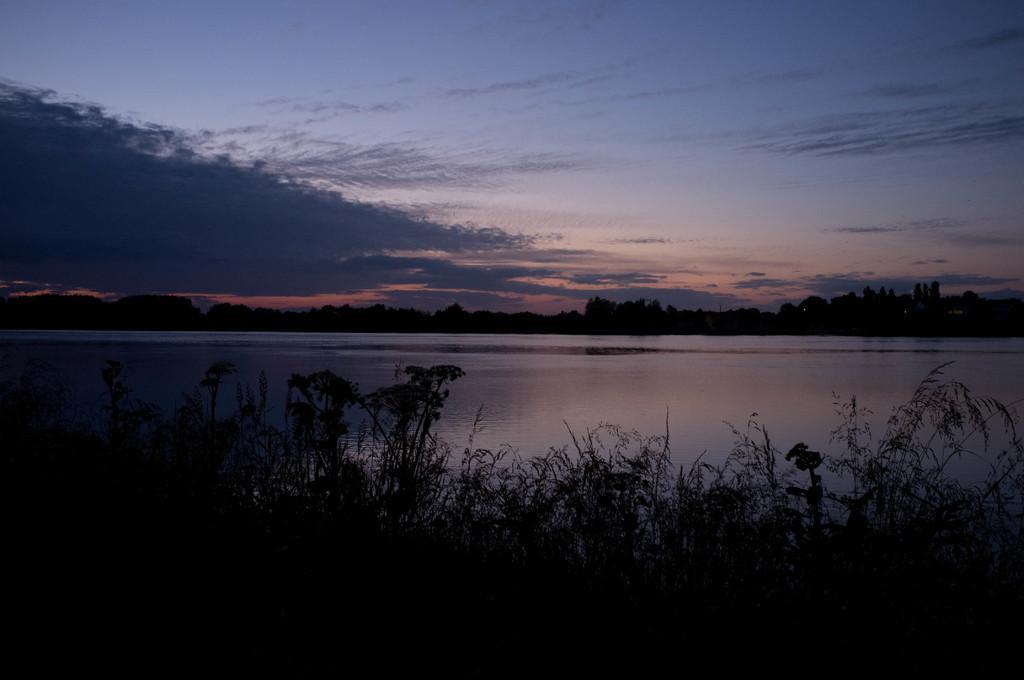Please provide a concise description of this image. In the foreground of the picture there are plants and trees. In the center of the picture there is a water body. In the background there are trees. At the top it is sky. 